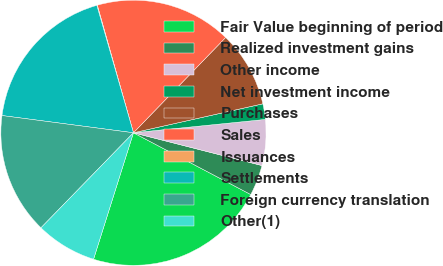Convert chart. <chart><loc_0><loc_0><loc_500><loc_500><pie_chart><fcel>Fair Value beginning of period<fcel>Realized investment gains<fcel>Other income<fcel>Net investment income<fcel>Purchases<fcel>Sales<fcel>Issuances<fcel>Settlements<fcel>Foreign currency translation<fcel>Other(1)<nl><fcel>22.15%<fcel>3.74%<fcel>5.58%<fcel>1.9%<fcel>9.26%<fcel>16.63%<fcel>0.06%<fcel>18.47%<fcel>14.79%<fcel>7.42%<nl></chart> 